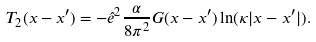<formula> <loc_0><loc_0><loc_500><loc_500>T _ { 2 } ( x - x ^ { \prime } ) = - \hat { e } ^ { 2 } \frac { \alpha } { 8 \pi ^ { 2 } } G ( x - x ^ { \prime } ) \ln ( \kappa | x - x ^ { \prime } | ) .</formula> 